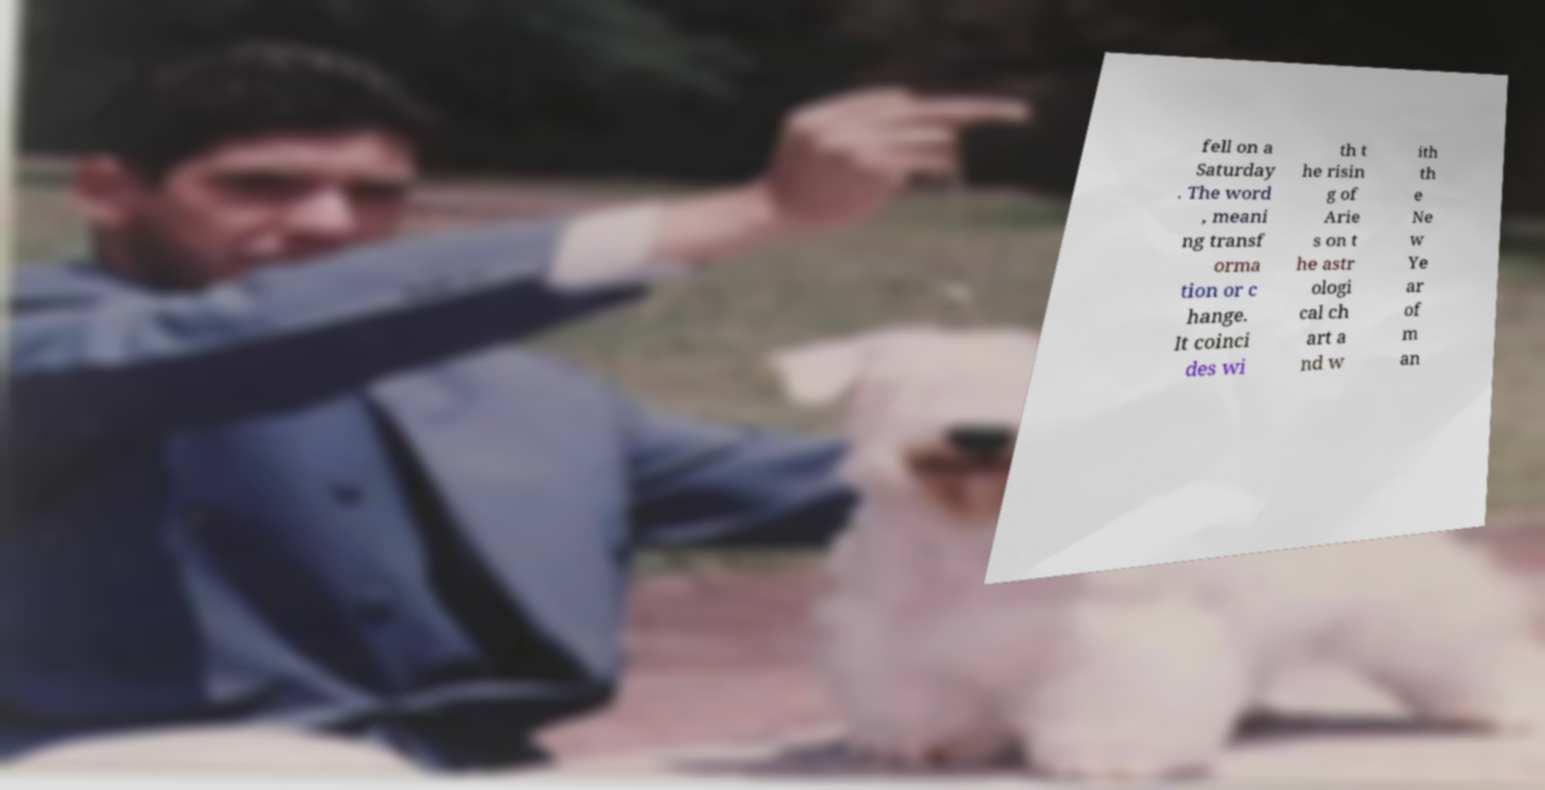For documentation purposes, I need the text within this image transcribed. Could you provide that? fell on a Saturday . The word , meani ng transf orma tion or c hange. It coinci des wi th t he risin g of Arie s on t he astr ologi cal ch art a nd w ith th e Ne w Ye ar of m an 